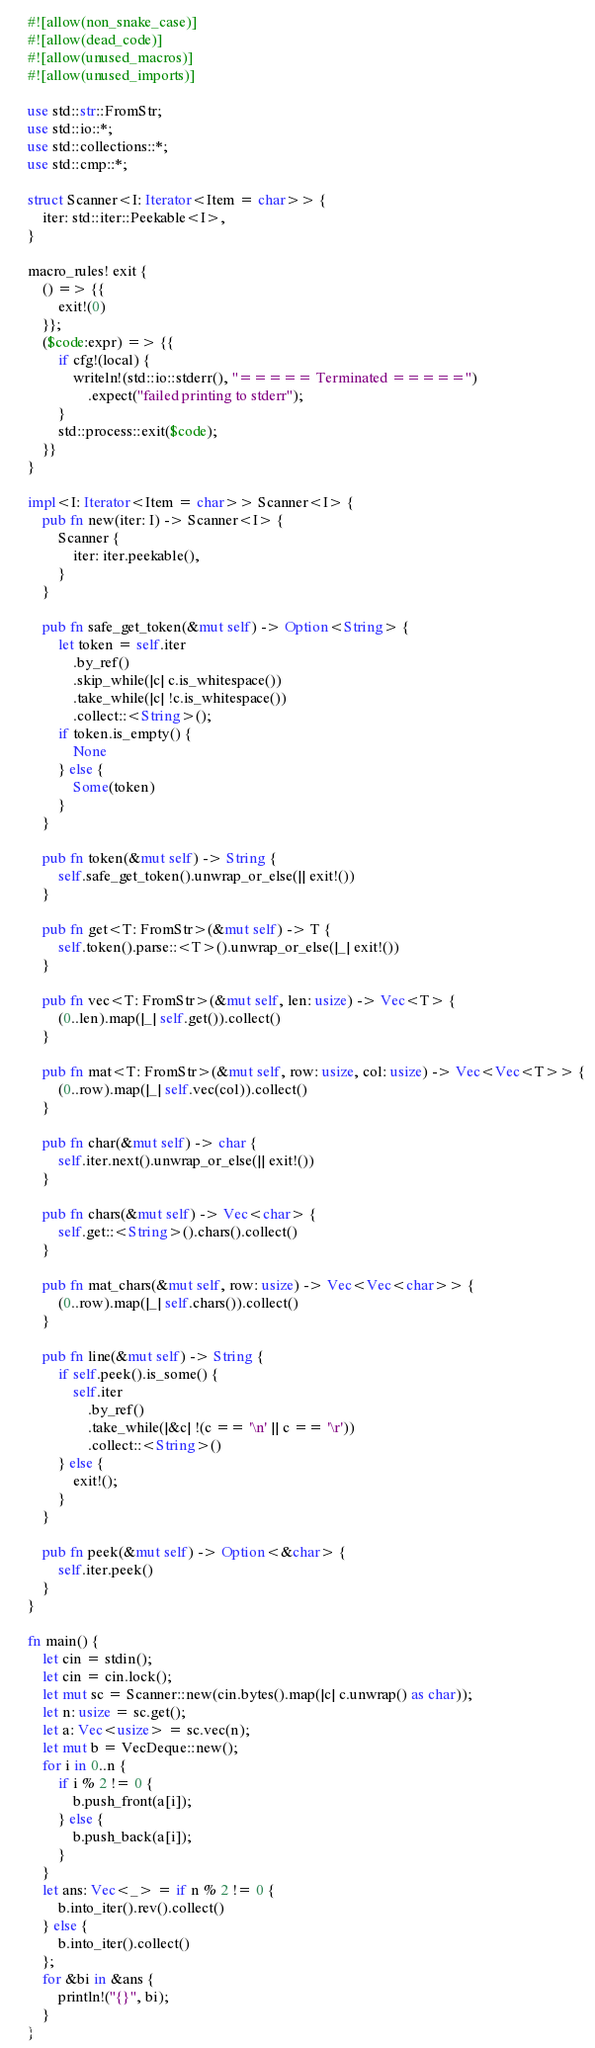<code> <loc_0><loc_0><loc_500><loc_500><_Rust_>#![allow(non_snake_case)]
#![allow(dead_code)]
#![allow(unused_macros)]
#![allow(unused_imports)]

use std::str::FromStr;
use std::io::*;
use std::collections::*;
use std::cmp::*;

struct Scanner<I: Iterator<Item = char>> {
    iter: std::iter::Peekable<I>,
}

macro_rules! exit {
    () => {{
        exit!(0)
    }};
    ($code:expr) => {{
        if cfg!(local) {
            writeln!(std::io::stderr(), "===== Terminated =====")
                .expect("failed printing to stderr");
        }
        std::process::exit($code);
    }}
}

impl<I: Iterator<Item = char>> Scanner<I> {
    pub fn new(iter: I) -> Scanner<I> {
        Scanner {
            iter: iter.peekable(),
        }
    }

    pub fn safe_get_token(&mut self) -> Option<String> {
        let token = self.iter
            .by_ref()
            .skip_while(|c| c.is_whitespace())
            .take_while(|c| !c.is_whitespace())
            .collect::<String>();
        if token.is_empty() {
            None
        } else {
            Some(token)
        }
    }

    pub fn token(&mut self) -> String {
        self.safe_get_token().unwrap_or_else(|| exit!())
    }

    pub fn get<T: FromStr>(&mut self) -> T {
        self.token().parse::<T>().unwrap_or_else(|_| exit!())
    }

    pub fn vec<T: FromStr>(&mut self, len: usize) -> Vec<T> {
        (0..len).map(|_| self.get()).collect()
    }

    pub fn mat<T: FromStr>(&mut self, row: usize, col: usize) -> Vec<Vec<T>> {
        (0..row).map(|_| self.vec(col)).collect()
    }

    pub fn char(&mut self) -> char {
        self.iter.next().unwrap_or_else(|| exit!())
    }

    pub fn chars(&mut self) -> Vec<char> {
        self.get::<String>().chars().collect()
    }

    pub fn mat_chars(&mut self, row: usize) -> Vec<Vec<char>> {
        (0..row).map(|_| self.chars()).collect()
    }

    pub fn line(&mut self) -> String {
        if self.peek().is_some() {
            self.iter
                .by_ref()
                .take_while(|&c| !(c == '\n' || c == '\r'))
                .collect::<String>()
        } else {
            exit!();
        }
    }

    pub fn peek(&mut self) -> Option<&char> {
        self.iter.peek()
    }
}

fn main() {
    let cin = stdin();
    let cin = cin.lock();
    let mut sc = Scanner::new(cin.bytes().map(|c| c.unwrap() as char));
    let n: usize = sc.get();
    let a: Vec<usize> = sc.vec(n);
    let mut b = VecDeque::new();
    for i in 0..n {
        if i % 2 != 0 {
            b.push_front(a[i]);
        } else {
            b.push_back(a[i]);
        }
    }
    let ans: Vec<_> = if n % 2 != 0 {
        b.into_iter().rev().collect()
    } else {
        b.into_iter().collect()
    };
    for &bi in &ans {
        println!("{}", bi);
    }
}
</code> 